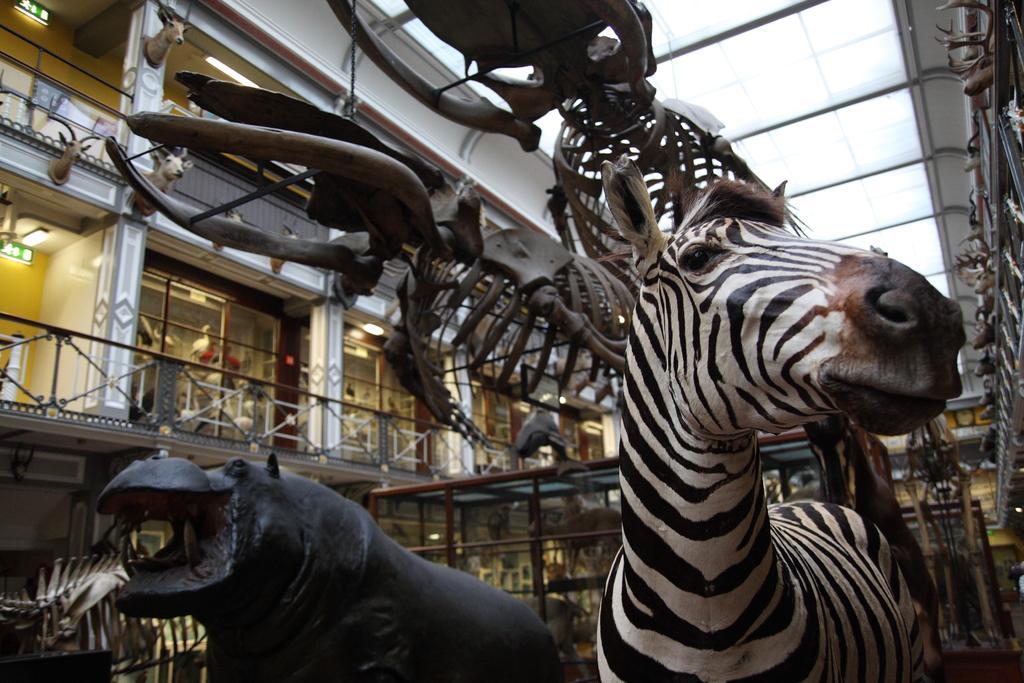Could you give a brief overview of what you see in this image? In this picture we can observe zebra on the right side. There is a statue of a hippopotamus on the left side. We can observe skeletons of dinosaurs. In the background there is a building and a railing. 